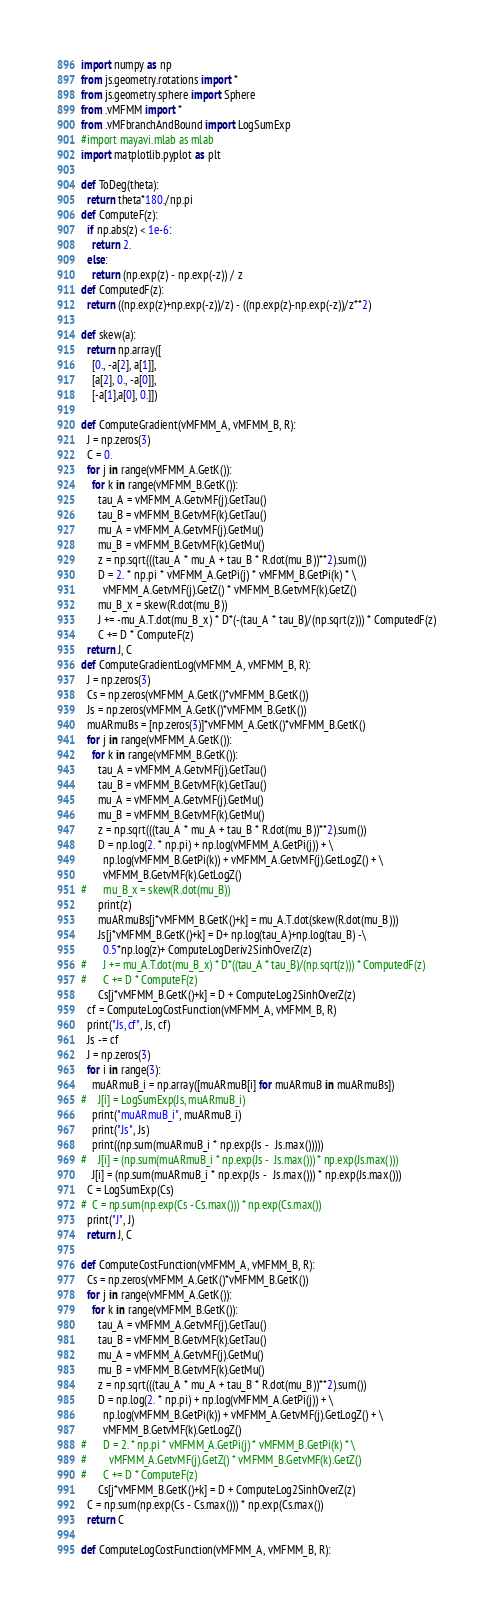<code> <loc_0><loc_0><loc_500><loc_500><_Python_>import numpy as np
from js.geometry.rotations import *
from js.geometry.sphere import Sphere
from .vMFMM import *
from .vMFbranchAndBound import LogSumExp
#import mayavi.mlab as mlab
import matplotlib.pyplot as plt

def ToDeg(theta):
  return theta*180./np.pi
def ComputeF(z):
  if np.abs(z) < 1e-6:
    return 2.
  else:
    return (np.exp(z) - np.exp(-z)) / z
def ComputedF(z):
  return ((np.exp(z)+np.exp(-z))/z) - ((np.exp(z)-np.exp(-z))/z**2)

def skew(a):
  return np.array([
    [0., -a[2], a[1]],
    [a[2], 0., -a[0]],
    [-a[1],a[0], 0.]])

def ComputeGradient(vMFMM_A, vMFMM_B, R):
  J = np.zeros(3)
  C = 0.
  for j in range(vMFMM_A.GetK()):
    for k in range(vMFMM_B.GetK()):
      tau_A = vMFMM_A.GetvMF(j).GetTau()
      tau_B = vMFMM_B.GetvMF(k).GetTau()
      mu_A = vMFMM_A.GetvMF(j).GetMu()
      mu_B = vMFMM_B.GetvMF(k).GetMu()
      z = np.sqrt(((tau_A * mu_A + tau_B * R.dot(mu_B))**2).sum())
      D = 2. * np.pi * vMFMM_A.GetPi(j) * vMFMM_B.GetPi(k) * \
        vMFMM_A.GetvMF(j).GetZ() * vMFMM_B.GetvMF(k).GetZ() 
      mu_B_x = skew(R.dot(mu_B))
      J += -mu_A.T.dot(mu_B_x) * D*(-(tau_A * tau_B)/(np.sqrt(z))) * ComputedF(z)
      C += D * ComputeF(z)
  return J, C
def ComputeGradientLog(vMFMM_A, vMFMM_B, R):
  J = np.zeros(3)
  Cs = np.zeros(vMFMM_A.GetK()*vMFMM_B.GetK())
  Js = np.zeros(vMFMM_A.GetK()*vMFMM_B.GetK())
  muARmuBs = [np.zeros(3)]*vMFMM_A.GetK()*vMFMM_B.GetK()
  for j in range(vMFMM_A.GetK()):
    for k in range(vMFMM_B.GetK()):
      tau_A = vMFMM_A.GetvMF(j).GetTau()
      tau_B = vMFMM_B.GetvMF(k).GetTau()
      mu_A = vMFMM_A.GetvMF(j).GetMu()
      mu_B = vMFMM_B.GetvMF(k).GetMu()
      z = np.sqrt(((tau_A * mu_A + tau_B * R.dot(mu_B))**2).sum())
      D = np.log(2. * np.pi) + np.log(vMFMM_A.GetPi(j)) + \
        np.log(vMFMM_B.GetPi(k)) + vMFMM_A.GetvMF(j).GetLogZ() + \
        vMFMM_B.GetvMF(k).GetLogZ() 
#      mu_B_x = skew(R.dot(mu_B))
      print(z)
      muARmuBs[j*vMFMM_B.GetK()+k] = mu_A.T.dot(skew(R.dot(mu_B)))
      Js[j*vMFMM_B.GetK()+k] = D+ np.log(tau_A)+np.log(tau_B) -\
        0.5*np.log(z)+ ComputeLogDeriv2SinhOverZ(z)
#      J += mu_A.T.dot(mu_B_x) * D*((tau_A * tau_B)/(np.sqrt(z))) * ComputedF(z)
#      C += D * ComputeF(z)
      Cs[j*vMFMM_B.GetK()+k] = D + ComputeLog2SinhOverZ(z)
  cf = ComputeLogCostFunction(vMFMM_A, vMFMM_B, R)
  print("Js, cf", Js, cf)
  Js -= cf
  J = np.zeros(3)
  for i in range(3):
    muARmuB_i = np.array([muARmuB[i] for muARmuB in muARmuBs])
#    J[i] = LogSumExp(Js, muARmuB_i)
    print("muARmuB_i", muARmuB_i)
    print("Js", Js)
    print((np.sum(muARmuB_i * np.exp(Js -  Js.max()))))
#    J[i] = (np.sum(muARmuB_i * np.exp(Js -  Js.max())) * np.exp(Js.max()))
    J[i] = (np.sum(muARmuB_i * np.exp(Js -  Js.max())) * np.exp(Js.max()))
  C = LogSumExp(Cs)
#  C = np.sum(np.exp(Cs - Cs.max())) * np.exp(Cs.max())
  print("J", J)
  return J, C

def ComputeCostFunction(vMFMM_A, vMFMM_B, R):
  Cs = np.zeros(vMFMM_A.GetK()*vMFMM_B.GetK())
  for j in range(vMFMM_A.GetK()):
    for k in range(vMFMM_B.GetK()):
      tau_A = vMFMM_A.GetvMF(j).GetTau()
      tau_B = vMFMM_B.GetvMF(k).GetTau()
      mu_A = vMFMM_A.GetvMF(j).GetMu()
      mu_B = vMFMM_B.GetvMF(k).GetMu()
      z = np.sqrt(((tau_A * mu_A + tau_B * R.dot(mu_B))**2).sum())
      D = np.log(2. * np.pi) + np.log(vMFMM_A.GetPi(j)) + \
        np.log(vMFMM_B.GetPi(k)) + vMFMM_A.GetvMF(j).GetLogZ() + \
        vMFMM_B.GetvMF(k).GetLogZ() 
#      D = 2. * np.pi * vMFMM_A.GetPi(j) * vMFMM_B.GetPi(k) * \
#        vMFMM_A.GetvMF(j).GetZ() * vMFMM_B.GetvMF(k).GetZ() 
#      C += D * ComputeF(z)
      Cs[j*vMFMM_B.GetK()+k] = D + ComputeLog2SinhOverZ(z)
  C = np.sum(np.exp(Cs - Cs.max())) * np.exp(Cs.max())
  return C

def ComputeLogCostFunction(vMFMM_A, vMFMM_B, R):</code> 